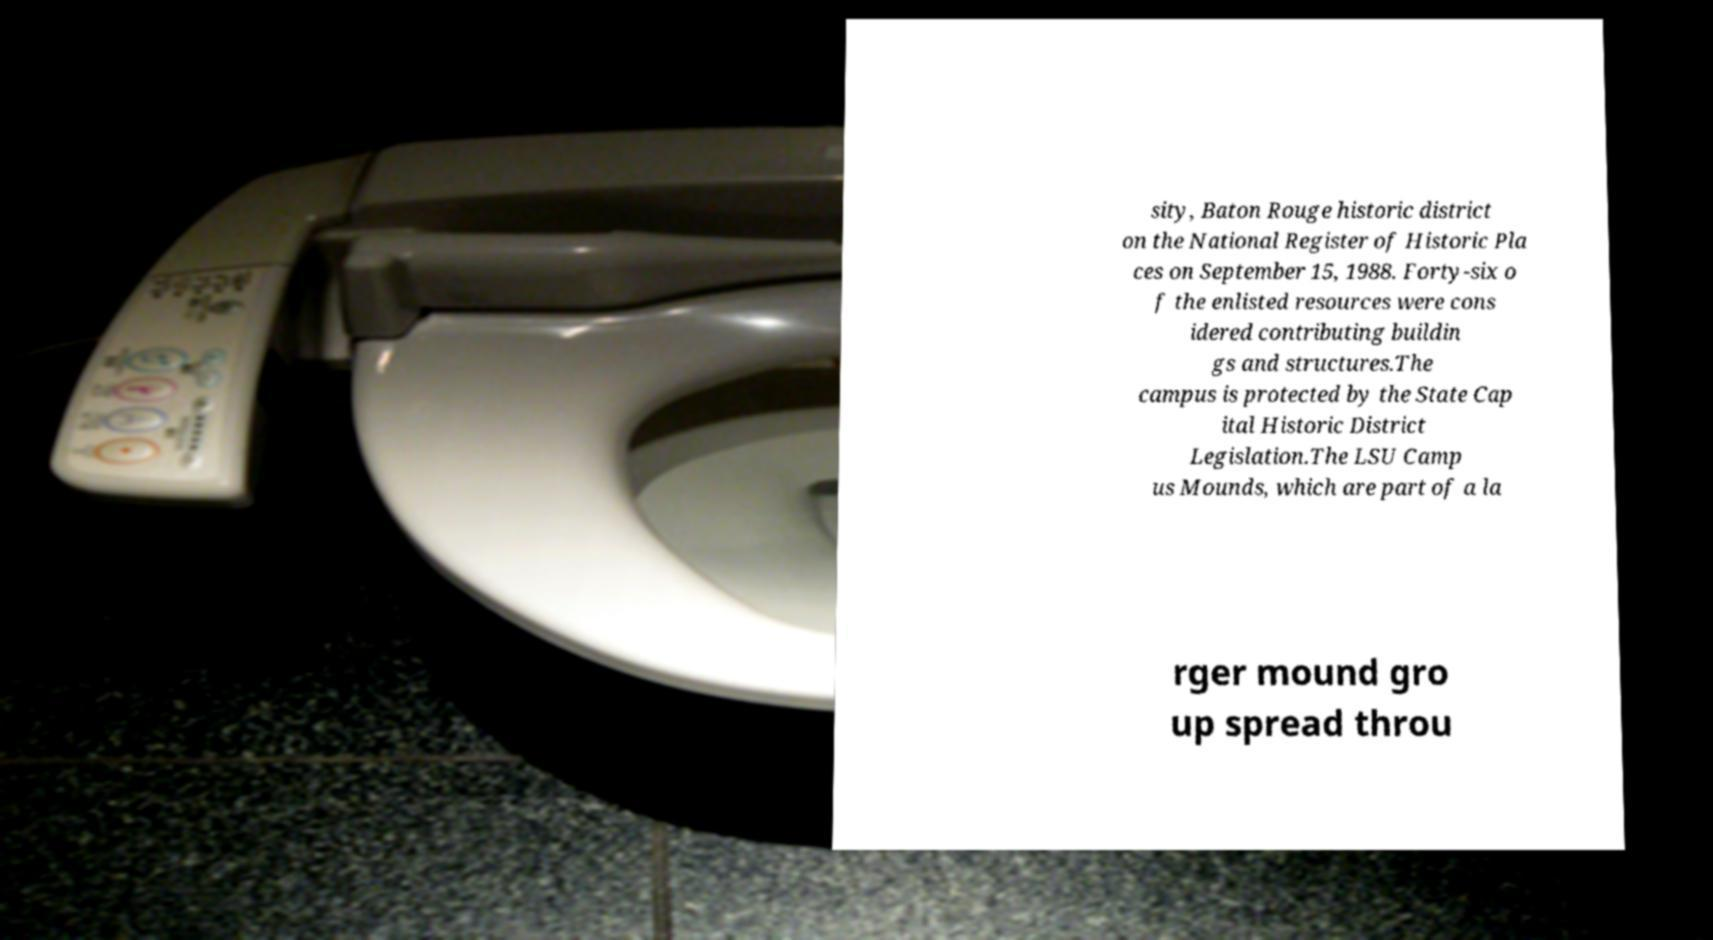What messages or text are displayed in this image? I need them in a readable, typed format. sity, Baton Rouge historic district on the National Register of Historic Pla ces on September 15, 1988. Forty-six o f the enlisted resources were cons idered contributing buildin gs and structures.The campus is protected by the State Cap ital Historic District Legislation.The LSU Camp us Mounds, which are part of a la rger mound gro up spread throu 